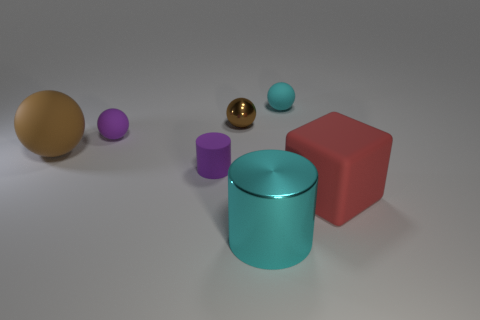How many brown balls must be subtracted to get 1 brown balls? 1 Subtract all shiny spheres. How many spheres are left? 3 Subtract all purple balls. How many balls are left? 3 Add 1 large red matte cubes. How many objects exist? 8 Subtract all gray balls. Subtract all brown cylinders. How many balls are left? 4 Subtract all large matte objects. Subtract all small green metallic things. How many objects are left? 5 Add 1 big red matte things. How many big red matte things are left? 2 Add 4 big red blocks. How many big red blocks exist? 5 Subtract 1 red blocks. How many objects are left? 6 Subtract all spheres. How many objects are left? 3 